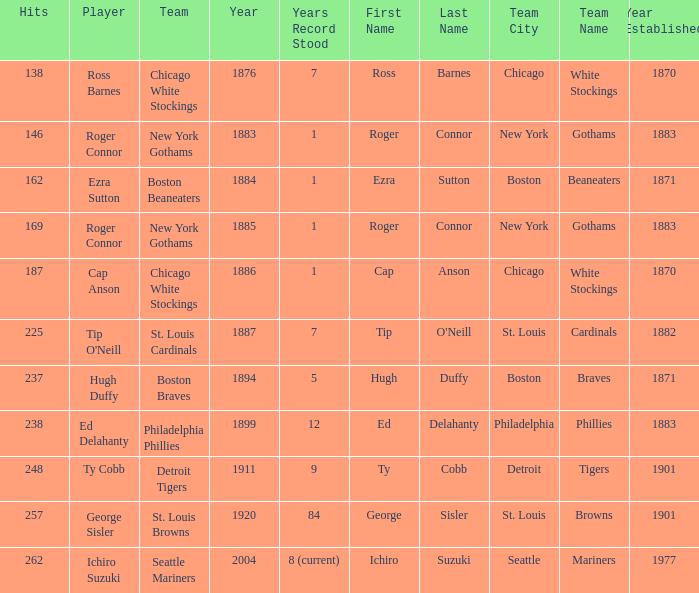Name the player with 238 hits and years after 1885 Ed Delahanty. 